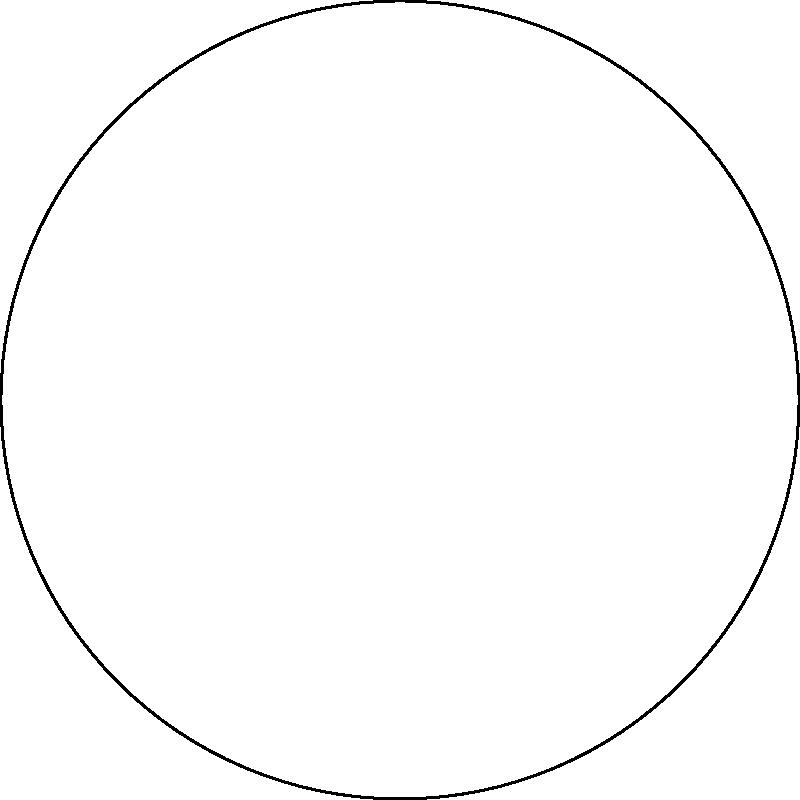In the context of Moroccan literature, imagine a storyteller describing a journey across the Sahara Desert using celestial navigation. The storyteller draws a spherical triangle on a globe to illustrate the path. If the angles of this spherical triangle are $\alpha = 70°$, $\beta = 80°$, and $\gamma = 100°$, what is the sum of these angles, and how does it differ from the sum of angles in a planar triangle? Explain the significance of this difference in relation to the vastness of the Sahara and the curvature of the Earth. To solve this problem, let's follow these steps:

1) First, recall that in Euclidean geometry (on a flat plane), the sum of angles in a triangle is always 180°.

2) However, on a sphere (like the surface of the Earth or a globe), we're dealing with non-Euclidean geometry. In spherical geometry, the sum of angles in a triangle is always greater than 180°.

3) Let's calculate the sum of the given angles:
   $\alpha + \beta + \gamma = 70° + 80° + 100° = 250°$

4) The difference between this sum and 180° is called the spherical excess (E):
   $E = (\alpha + \beta + \gamma) - 180°$
   $E = 250° - 180° = 70°$

5) This excess is directly related to the area of the spherical triangle. In fact, if R is the radius of the sphere, the area (A) of the spherical triangle is given by:
   $A = R^2E$ (where E is in radians)

6) The significance in the context of the Sahara and Earth's curvature:
   - The larger the spherical excess, the larger the area of the triangle on the sphere's surface.
   - This illustrates how the vastness of the Sahara, when mapped onto a globe, creates triangles with angle sums significantly larger than 180°.
   - It demonstrates that over large distances on Earth, we can't ignore the curvature and must use spherical geometry for accurate navigation.

This concept could be used in Moroccan literature to symbolize how traditional knowledge (like celestial navigation) inherently understood and accounted for the Earth's true shape, even before modern scientific explanations.
Answer: 250°, exceeding 180° by 70° due to Earth's curvature. 